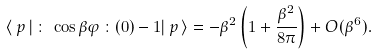<formula> <loc_0><loc_0><loc_500><loc_500>\langle \, p \, | \, \colon \, \cos \beta \varphi \, \colon ( 0 ) - 1 | \, p \, \rangle = - \beta ^ { 2 } \left ( 1 + \frac { \beta ^ { 2 } } { 8 \pi } \right ) + O ( \beta ^ { 6 } ) .</formula> 